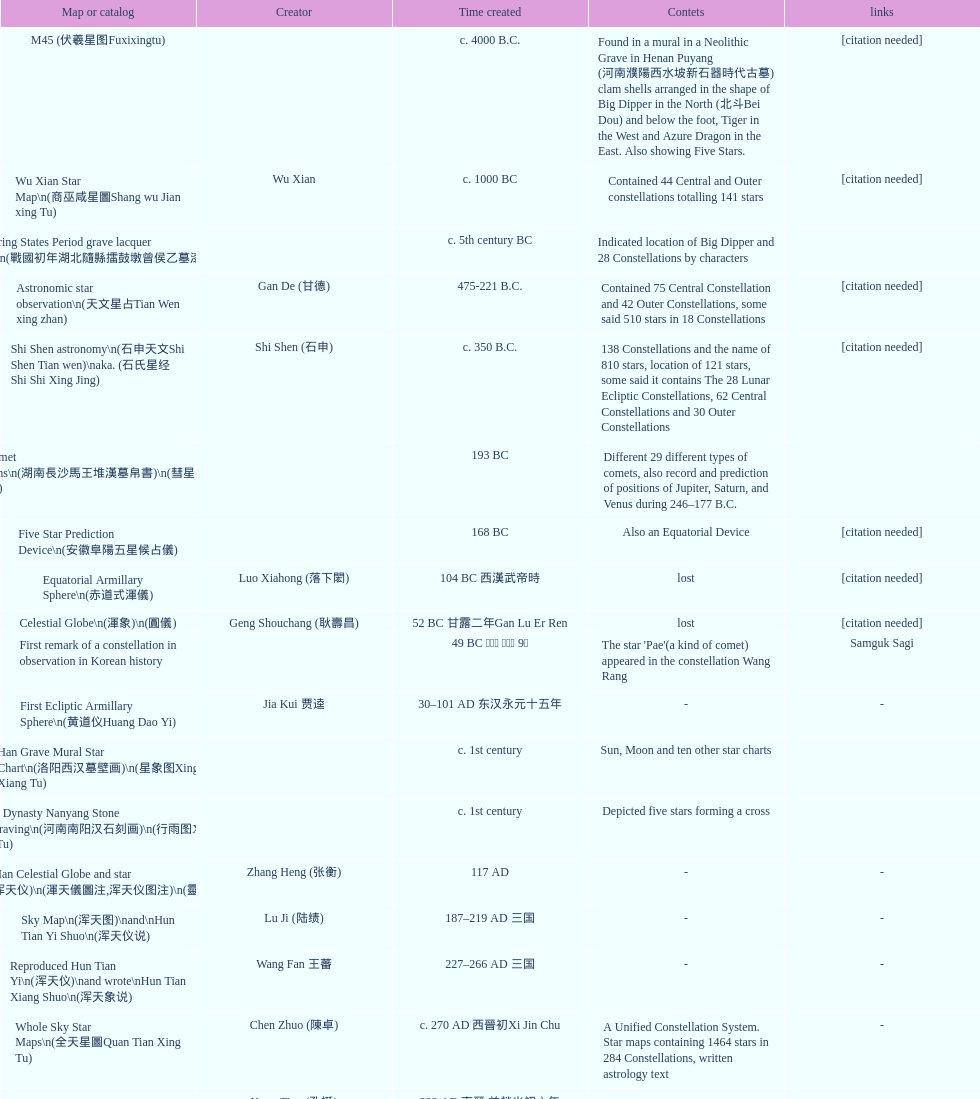Which chinese star map was the first one to be made? M45 (伏羲星图Fuxixingtu). 